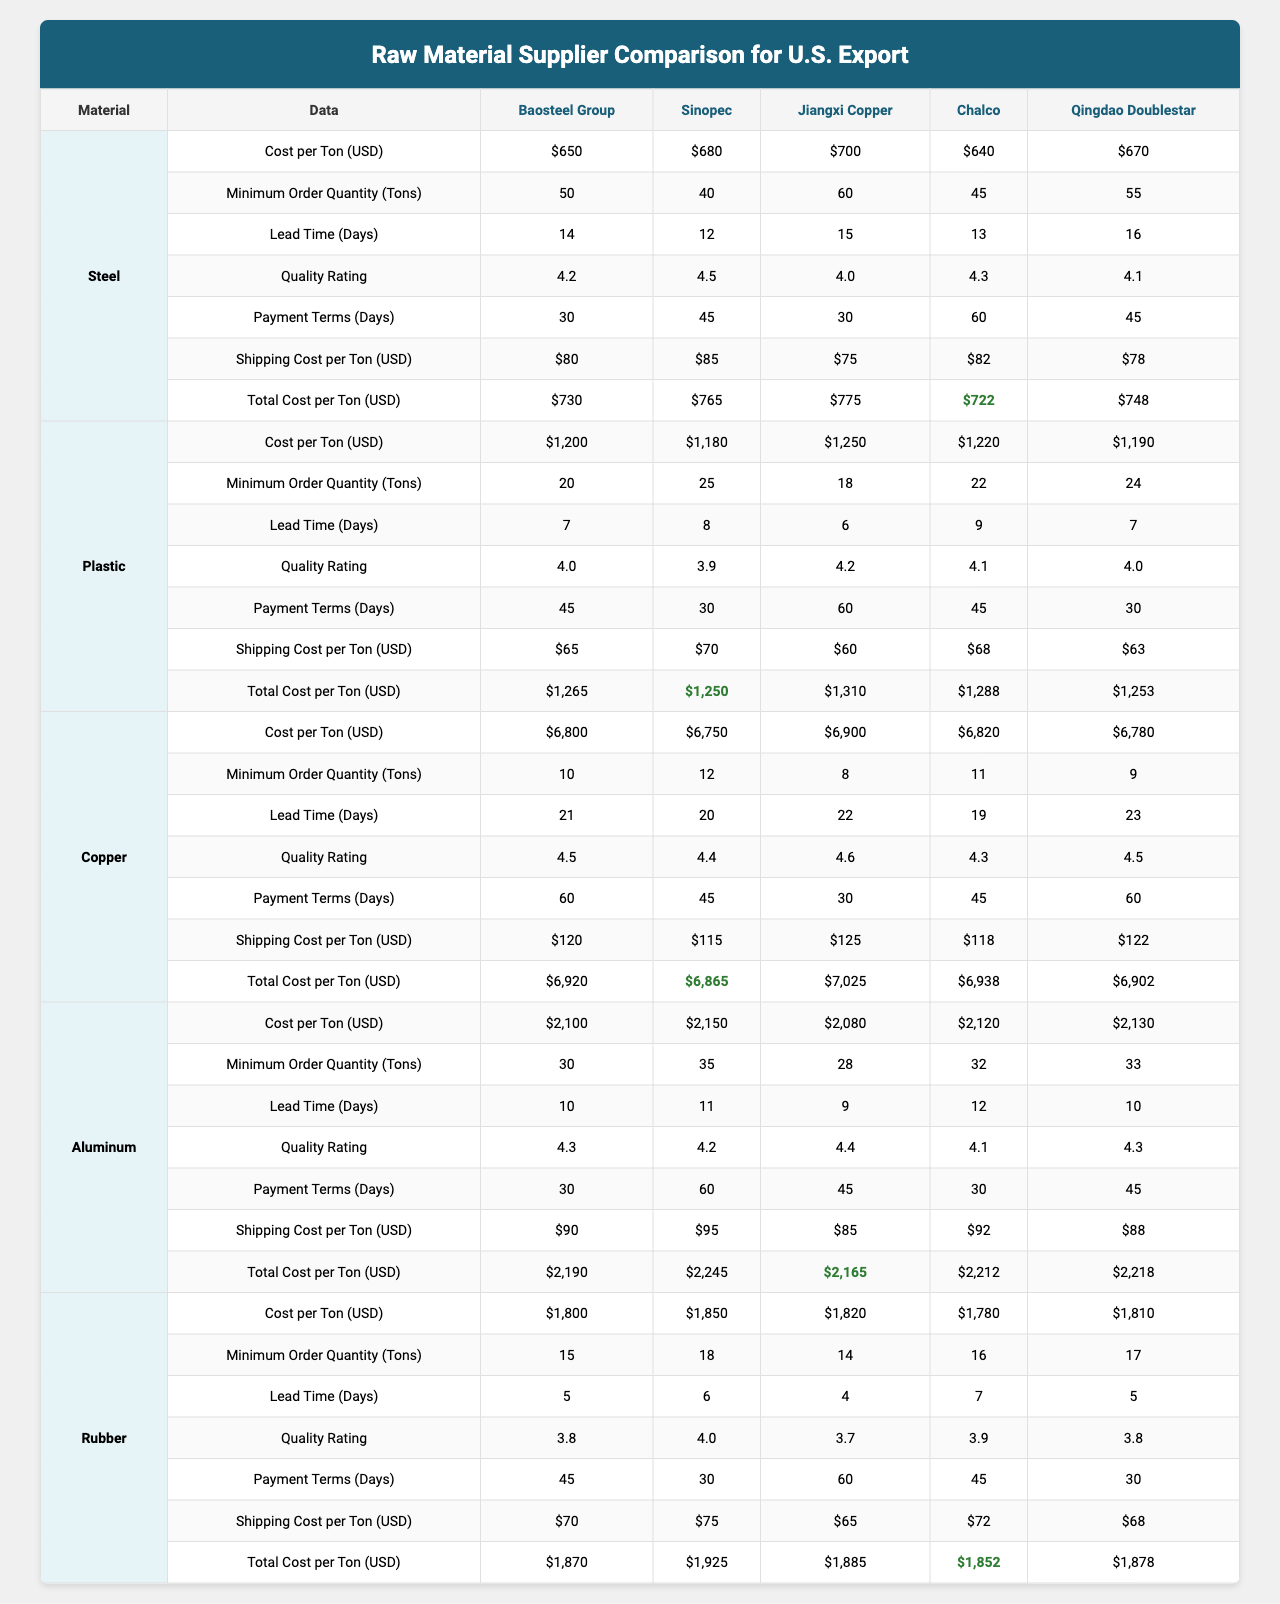What is the cost per ton of Steel from Baosteel Group? According to the table, the cost per ton of Steel from Baosteel Group is listed as $650.
Answer: $650 Which supplier offers the lowest shipping cost for Plastic? The shipping costs for Plastic from different suppliers are as follows: $80, $85, $75, $90, and $70. The lowest shipping cost is $60 from Jiangxi Copper.
Answer: $60 What is the minimum order quantity for Rubber from Chalco? The minimum order quantity for Rubber from Chalco is 16 tons, as indicated in the table.
Answer: 16 tons What is the lead time in days for Aluminum from Qingdao Doublestar? The lead time for Aluminum from Qingdao Doublestar is recorded as 10 days in the table.
Answer: 10 days Which raw material has the highest average quality rating? The average quality ratings for each material are as follows: Steel (4.2), Plastic (4.0), Copper (4.5), Aluminum (4.3), and Rubber (3.8). The highest average quality rating is for Copper at 4.5.
Answer: Copper What is the total cost per ton of Copper from Jiangxi Copper? The total cost per ton of Copper from Jiangxi Copper is calculated by adding the cost per ton ($6,800) and the shipping cost ($120), which equals $6,920.
Answer: $6,920 Is the quality rating for Plastic from Sinopec higher than 4.0? The quality rating for Plastic from Sinopec is 3.9, which is not higher than 4.0. Hence, the statement is false.
Answer: False Which supplier offers the best total cost per ton for Steel? The total costs per ton for Steel are as follows: Baosteel Group ($730), Sinopec ($765), Jiangxi Copper ($6,920), Chalco ($2,190), and Qingdao Doublestar ($748). The best value is from Baosteel Group at $730.
Answer: Baosteel Group What is the average lead time for Rubber across all suppliers? The lead times for Rubber across all suppliers are 5, 6, 4, 7, and 5 days. To find the average, sum them up (5 + 6 + 4 + 7 + 5 = 27) and divide by the number of suppliers (27/5 = 5.4).
Answer: 5.4 days Which supplier has the highest minimum order quantity for Steel? The minimum order quantities for Steel from suppliers are as follows: 50 (Baosteel Group), 40 (Sinopec), 60 (Jiangxi Copper), 45 (Chalco), and 55 (Qingdao Doublestar). Jiangxi Copper has the highest minimum order quantity of 60 tons.
Answer: Jiangxi Copper What are the payment terms in days for Copper from Jiangxi Copper? The payment terms for Copper from Jiangxi Copper are 30 days. This is indicated explicitly in the table.
Answer: 30 days Which material has the longest lead time on average? The average lead times for each material are: Steel (14 days), Plastic (7 days), Copper (21 days), Aluminum (10 days), and Rubber (5 days). Copper has the longest average lead time of 21 days.
Answer: Copper 